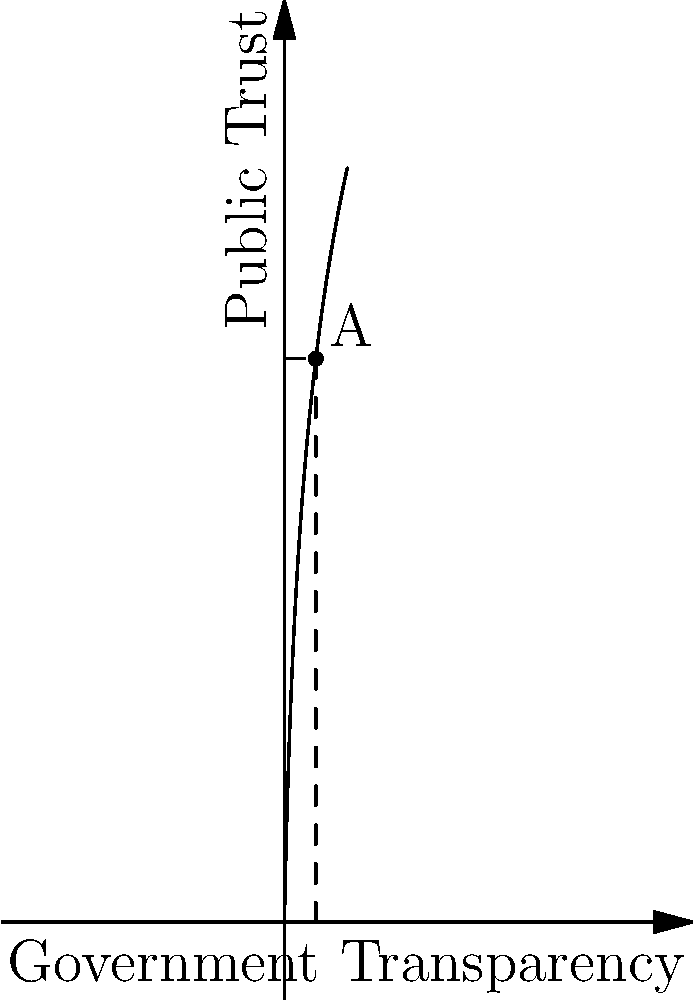The graph shows the relationship between government transparency and public trust. At point A, where the government transparency level is 5, what is the slope of the tangent line to the curve? This represents the rate of change in public trust with respect to transparency at that point. To find the slope of the tangent line at point A, we need to calculate the derivative of the function at x = 5.

The function appears to be of the form:
$$f(x) = 50\ln(x+1)$$

The derivative of this function is:
$$f'(x) = \frac{50}{x+1}$$

At x = 5:
$$f'(5) = \frac{50}{5+1} = \frac{50}{6}$$

Simplifying:
$$f'(5) = \frac{25}{3} \approx 8.33$$

This value represents the instantaneous rate of change of public trust with respect to government transparency at the point where transparency level is 5.
Answer: $\frac{25}{3}$ 